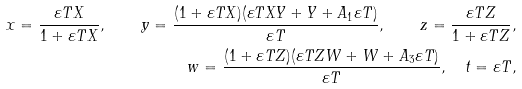<formula> <loc_0><loc_0><loc_500><loc_500>x = \frac { \varepsilon T X } { 1 + \varepsilon T X } , \quad y = \frac { ( 1 + \varepsilon T X ) ( \varepsilon T X Y + Y + A _ { 1 } \varepsilon T ) } { \varepsilon T } , \quad z = \frac { \varepsilon T Z } { 1 + \varepsilon T Z } , \\ w = \frac { ( 1 + \varepsilon T Z ) ( \varepsilon T Z W + W + A _ { 3 } \varepsilon T ) } { \varepsilon T } , \quad t = \varepsilon T ,</formula> 